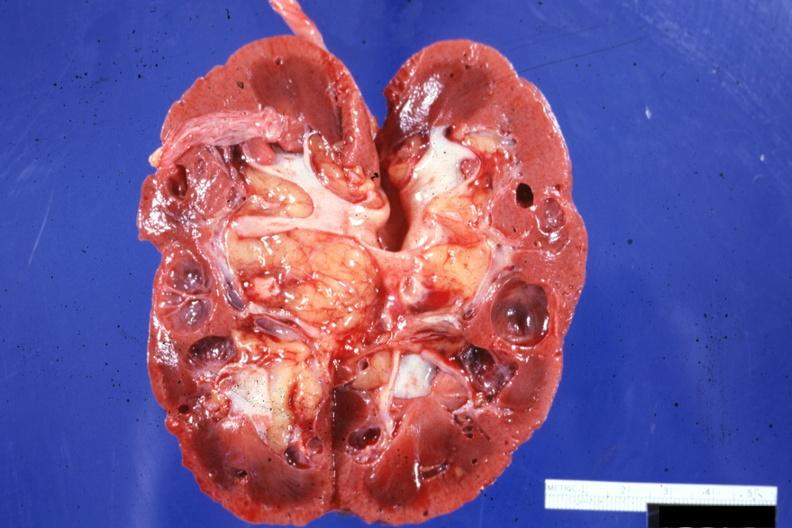where is this?
Answer the question using a single word or phrase. Urinary 